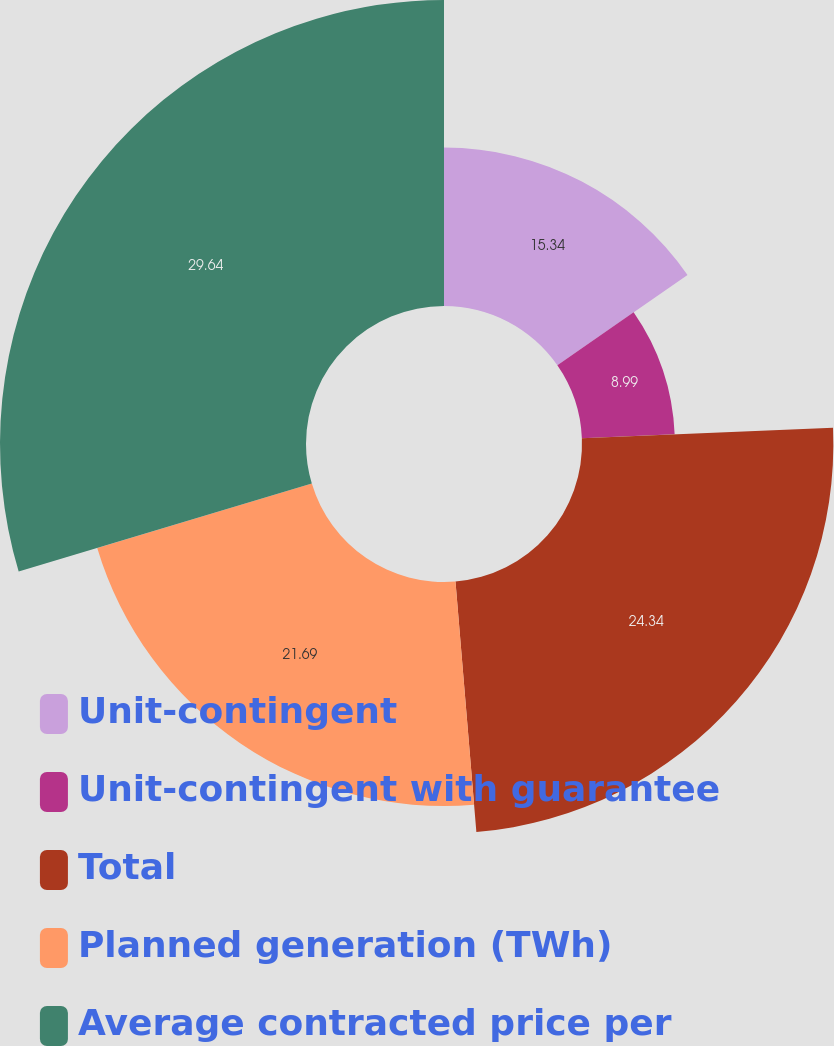Convert chart. <chart><loc_0><loc_0><loc_500><loc_500><pie_chart><fcel>Unit-contingent<fcel>Unit-contingent with guarantee<fcel>Total<fcel>Planned generation (TWh)<fcel>Average contracted price per<nl><fcel>15.34%<fcel>8.99%<fcel>24.34%<fcel>21.69%<fcel>29.63%<nl></chart> 